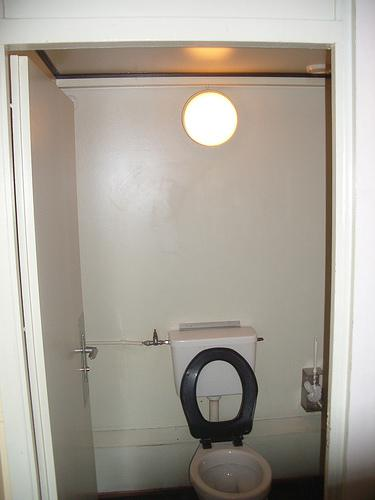Question: how many doors are open in the scene?
Choices:
A. One.
B. Two.
C. Four.
D. Five.
Answer with the letter. Answer: A Question: how many toilets are in the photo?
Choices:
A. One.
B. Six.
C. Seven.
D. Two.
Answer with the letter. Answer: A Question: what is reflecting on the ceiling in the middle of the photo?
Choices:
A. The sun.
B. The wall light.
C. The moon.
D. A headlight.
Answer with the letter. Answer: B Question: what kind of room is this?
Choices:
A. Ballroom.
B. Bathroom.
C. Livingroom.
D. Hallway.
Answer with the letter. Answer: B Question: where is this scene taking place?
Choices:
A. Bedroom.
B. In the bathroom.
C. Kitchen.
D. Basement.
Answer with the letter. Answer: B 